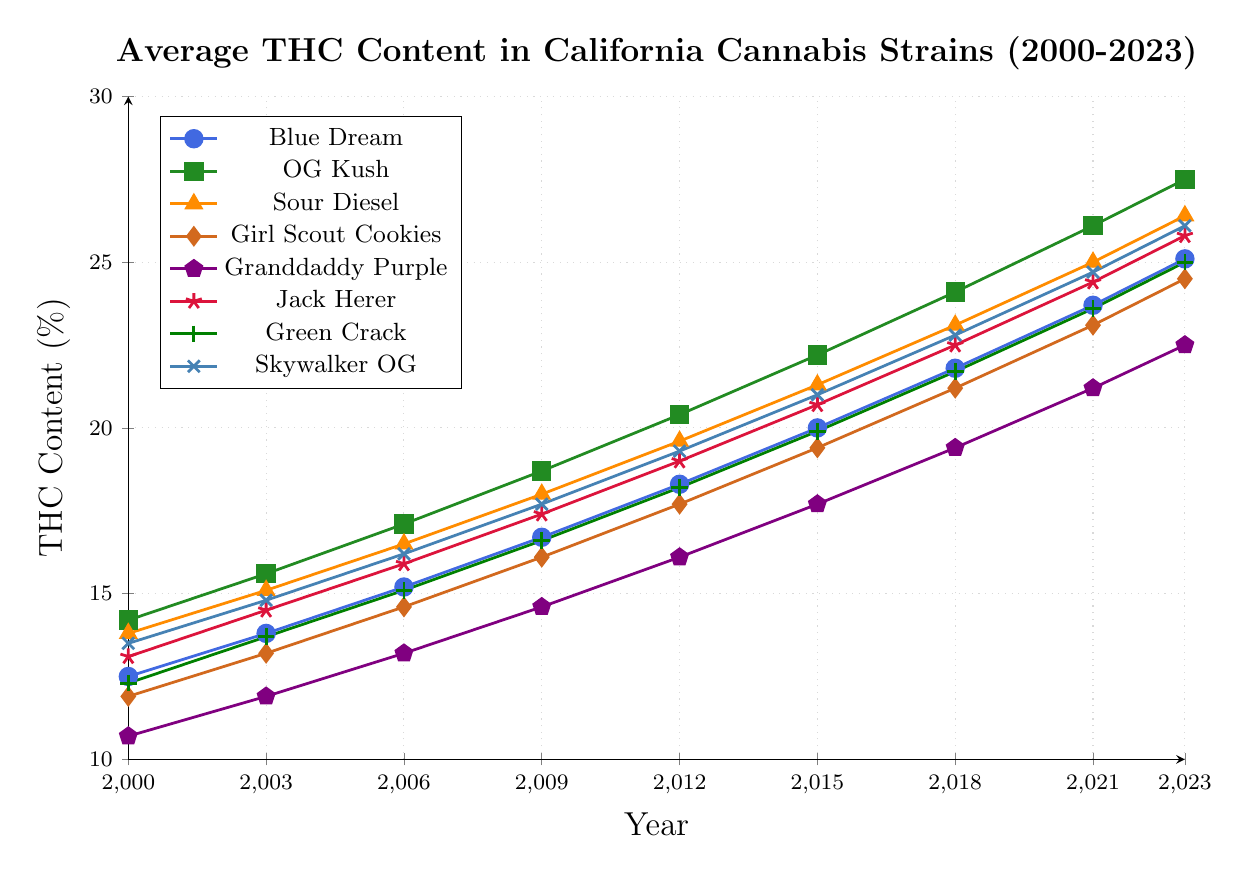Which strain had the highest THC content in 2023? To find the strain with the highest THC content in 2023, look at the data for 2023 and identify the strain with the highest value. OG Kush has the highest THC content of 27.5%.
Answer: OG Kush By how much did the THC content of Skywalker OG increase from 2000 to 2023? Compare the THC content of Skywalker OG in 2000 (13.5%) to its content in 2023 (26.1%). Subtract the 2000 value from the 2023 value: 26.1 - 13.5 = 12.6.
Answer: 12.6% Which strain had the lowest THC increase from 2000 to 2023? Calculate the increase for each strain from 2000 to 2023 by subtracting the 2000 THC content from the 2023 THC content. Granddaddy Purple increased from 10.7% to 22.5%, which is an increase of 11.8%, the lowest among the strains.
Answer: Granddaddy Purple How does the THC content of Sour Diesel in 2012 compare to that of Green Crack in the same year? Look at the THC content for both Sour Diesel and Green Crack in 2012. Sour Diesel has 19.6% while Green Crack has 18.2%. Sour Diesel's THC content is higher.
Answer: Sour Diesel's THC content is higher What is the average THC content of Blue Dream from 2000 to 2023? Sum up the THC content of Blue Dream for the years provided and divide by the number of data points. (12.5 + 13.8 + 15.2 + 16.7 + 18.3 + 20.0 + 21.8 + 23.7 + 25.1) / 9 = 18.8.
Answer: 18.8% Which strains have a THC content of over 25% in 2023? Look at the THC content for each strain in 2023 and list those with values over 25%. OG Kush, Sour Diesel, Jack Herer, and Skywalker OG all have THC contents over 25% in 2023.
Answer: OG Kush, Sour Diesel, Jack Herer, Skywalker OG Between 2003 and 2009, which strain had the greatest increase in THC content? Calculate the increase for each strain from 2003 to 2009, and identify the greatest increase. OG Kush increased from 15.6% to 18.7%, an increase of 3.1%, which is the greatest.
Answer: OG Kush On average, how much did the THC content for Jack Herer increase per year from 2000 to 2023? Find the total increase for Jack Herer from 2000 to 2023 and divide by the number of years. Increase = 25.8% - 13.1% = 12.7%; number of years = 2023 - 2000 = 23. Average increase per year = 12.7 / 23 ≈ 0.55.
Answer: 0.55% per year Is the THC content of Girl Scout Cookies in 2021 higher or lower than that of Blue Dream in 2018? Compare the THC content of Girl Scout Cookies in 2021 (23.1%) with that of Blue Dream in 2018 (21.8%). Girl Scout Cookies' THC content in 2021 is higher.
Answer: Higher 